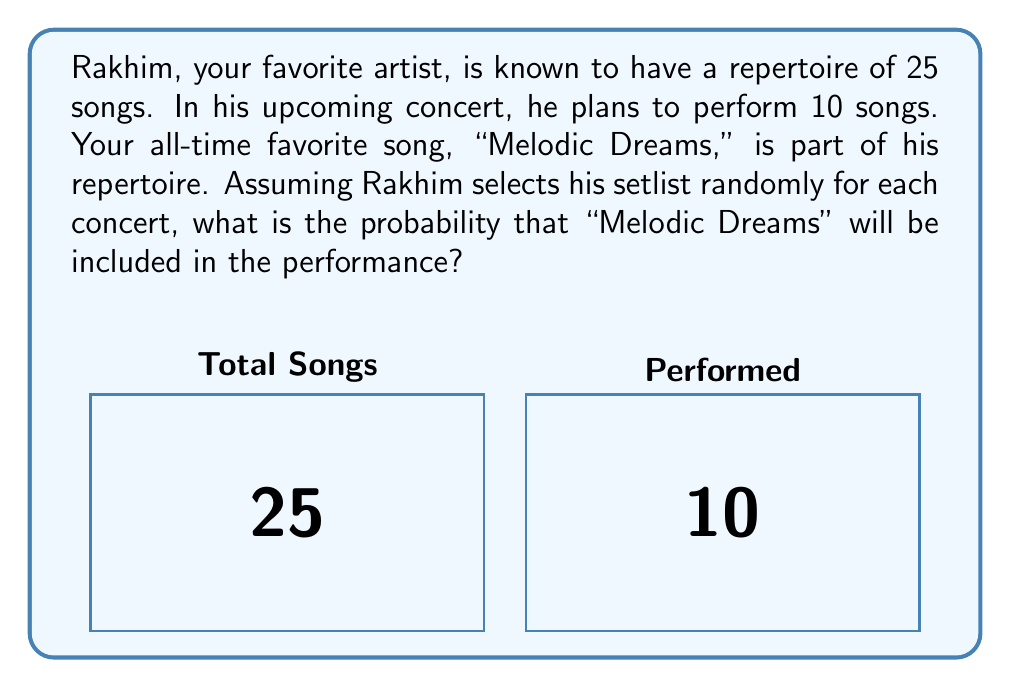Provide a solution to this math problem. Let's approach this step-by-step:

1) This is a problem of combination without replacement. We can use the hypergeometric distribution to solve it.

2) The probability of "Melodic Dreams" being included is equal to 1 minus the probability of it not being included.

3) Let's define our variables:
   - N = total number of songs = 25
   - K = number of favorable outcomes (songs including "Melodic Dreams") = 1
   - n = number of songs performed = 10
   - k = number of successes we're looking for = 0 (as we're calculating the probability of not including the song)

4) The hypergeometric probability formula is:

   $$P(X=k) = \frac{\binom{K}{k}\binom{N-K}{n-k}}{\binom{N}{n}}$$

5) Plugging in our values:

   $$P(X=0) = \frac{\binom{1}{0}\binom{24}{10}}{\binom{25}{10}}$$

6) Simplify:
   $$P(X=0) = \frac{1 \cdot \binom{24}{10}}{\binom{25}{10}}$$

7) Calculate the combinations:
   $$P(X=0) = \frac{1 \cdot 1,961,256}{3,268,760} = 0.6$$

8) Therefore, the probability of not including "Melodic Dreams" is 0.6.

9) The probability of including "Melodic Dreams" is:
   $$P(\text{including}) = 1 - P(\text{not including}) = 1 - 0.6 = 0.4$$

Thus, there's a 40% chance that "Melodic Dreams" will be included in the concert.
Answer: $0.4$ or $40\%$ 